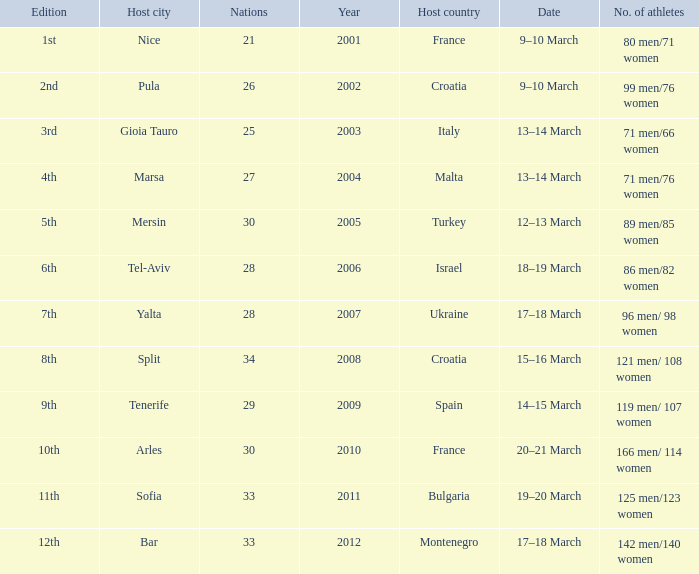What was the most recent year? 2012.0. 